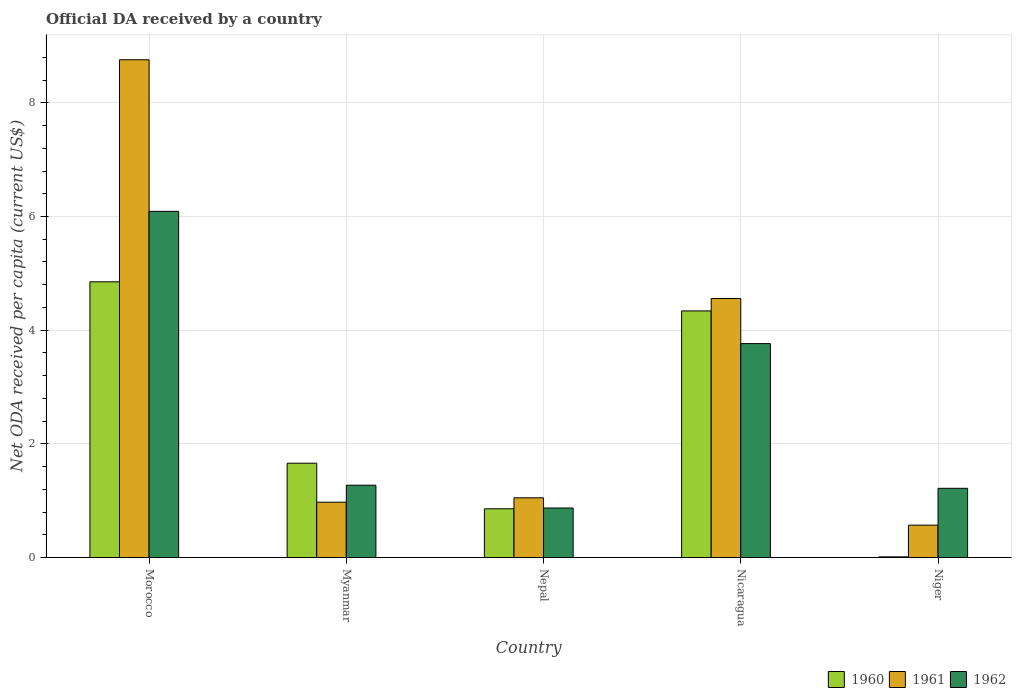How many different coloured bars are there?
Ensure brevity in your answer.  3. Are the number of bars on each tick of the X-axis equal?
Make the answer very short. Yes. How many bars are there on the 1st tick from the right?
Your answer should be very brief. 3. What is the label of the 1st group of bars from the left?
Your answer should be compact. Morocco. What is the ODA received in in 1961 in Myanmar?
Give a very brief answer. 0.97. Across all countries, what is the maximum ODA received in in 1962?
Keep it short and to the point. 6.09. Across all countries, what is the minimum ODA received in in 1961?
Keep it short and to the point. 0.57. In which country was the ODA received in in 1960 maximum?
Provide a succinct answer. Morocco. In which country was the ODA received in in 1962 minimum?
Your answer should be very brief. Nepal. What is the total ODA received in in 1962 in the graph?
Your response must be concise. 13.22. What is the difference between the ODA received in in 1962 in Morocco and that in Niger?
Offer a very short reply. 4.87. What is the difference between the ODA received in in 1962 in Myanmar and the ODA received in in 1960 in Niger?
Give a very brief answer. 1.26. What is the average ODA received in in 1961 per country?
Give a very brief answer. 3.18. What is the difference between the ODA received in of/in 1961 and ODA received in of/in 1960 in Morocco?
Provide a succinct answer. 3.91. What is the ratio of the ODA received in in 1961 in Nicaragua to that in Niger?
Your answer should be compact. 8. What is the difference between the highest and the second highest ODA received in in 1960?
Ensure brevity in your answer.  -3.19. What is the difference between the highest and the lowest ODA received in in 1960?
Make the answer very short. 4.84. Is the sum of the ODA received in in 1961 in Nepal and Niger greater than the maximum ODA received in in 1960 across all countries?
Give a very brief answer. No. What does the 1st bar from the left in Morocco represents?
Ensure brevity in your answer.  1960. Is it the case that in every country, the sum of the ODA received in in 1962 and ODA received in in 1960 is greater than the ODA received in in 1961?
Offer a terse response. Yes. How many bars are there?
Give a very brief answer. 15. How many countries are there in the graph?
Your answer should be very brief. 5. Are the values on the major ticks of Y-axis written in scientific E-notation?
Provide a succinct answer. No. Does the graph contain any zero values?
Your answer should be compact. No. Does the graph contain grids?
Make the answer very short. Yes. Where does the legend appear in the graph?
Provide a short and direct response. Bottom right. How many legend labels are there?
Offer a terse response. 3. What is the title of the graph?
Provide a succinct answer. Official DA received by a country. Does "1986" appear as one of the legend labels in the graph?
Make the answer very short. No. What is the label or title of the Y-axis?
Provide a short and direct response. Net ODA received per capita (current US$). What is the Net ODA received per capita (current US$) in 1960 in Morocco?
Your answer should be compact. 4.85. What is the Net ODA received per capita (current US$) of 1961 in Morocco?
Ensure brevity in your answer.  8.76. What is the Net ODA received per capita (current US$) in 1962 in Morocco?
Your response must be concise. 6.09. What is the Net ODA received per capita (current US$) in 1960 in Myanmar?
Your response must be concise. 1.66. What is the Net ODA received per capita (current US$) of 1961 in Myanmar?
Your answer should be compact. 0.97. What is the Net ODA received per capita (current US$) in 1962 in Myanmar?
Provide a succinct answer. 1.27. What is the Net ODA received per capita (current US$) in 1960 in Nepal?
Offer a very short reply. 0.86. What is the Net ODA received per capita (current US$) in 1961 in Nepal?
Offer a very short reply. 1.05. What is the Net ODA received per capita (current US$) in 1962 in Nepal?
Ensure brevity in your answer.  0.87. What is the Net ODA received per capita (current US$) in 1960 in Nicaragua?
Keep it short and to the point. 4.34. What is the Net ODA received per capita (current US$) in 1961 in Nicaragua?
Keep it short and to the point. 4.56. What is the Net ODA received per capita (current US$) in 1962 in Nicaragua?
Offer a very short reply. 3.76. What is the Net ODA received per capita (current US$) in 1960 in Niger?
Your response must be concise. 0.01. What is the Net ODA received per capita (current US$) in 1961 in Niger?
Provide a short and direct response. 0.57. What is the Net ODA received per capita (current US$) of 1962 in Niger?
Your response must be concise. 1.22. Across all countries, what is the maximum Net ODA received per capita (current US$) of 1960?
Provide a succinct answer. 4.85. Across all countries, what is the maximum Net ODA received per capita (current US$) in 1961?
Offer a terse response. 8.76. Across all countries, what is the maximum Net ODA received per capita (current US$) in 1962?
Your response must be concise. 6.09. Across all countries, what is the minimum Net ODA received per capita (current US$) of 1960?
Ensure brevity in your answer.  0.01. Across all countries, what is the minimum Net ODA received per capita (current US$) of 1961?
Provide a succinct answer. 0.57. Across all countries, what is the minimum Net ODA received per capita (current US$) of 1962?
Offer a terse response. 0.87. What is the total Net ODA received per capita (current US$) in 1960 in the graph?
Provide a succinct answer. 11.72. What is the total Net ODA received per capita (current US$) of 1961 in the graph?
Provide a succinct answer. 15.91. What is the total Net ODA received per capita (current US$) of 1962 in the graph?
Ensure brevity in your answer.  13.22. What is the difference between the Net ODA received per capita (current US$) in 1960 in Morocco and that in Myanmar?
Give a very brief answer. 3.19. What is the difference between the Net ODA received per capita (current US$) in 1961 in Morocco and that in Myanmar?
Your answer should be very brief. 7.78. What is the difference between the Net ODA received per capita (current US$) in 1962 in Morocco and that in Myanmar?
Your response must be concise. 4.82. What is the difference between the Net ODA received per capita (current US$) of 1960 in Morocco and that in Nepal?
Make the answer very short. 3.99. What is the difference between the Net ODA received per capita (current US$) in 1961 in Morocco and that in Nepal?
Your response must be concise. 7.71. What is the difference between the Net ODA received per capita (current US$) of 1962 in Morocco and that in Nepal?
Your answer should be very brief. 5.22. What is the difference between the Net ODA received per capita (current US$) of 1960 in Morocco and that in Nicaragua?
Ensure brevity in your answer.  0.51. What is the difference between the Net ODA received per capita (current US$) of 1961 in Morocco and that in Nicaragua?
Your answer should be compact. 4.2. What is the difference between the Net ODA received per capita (current US$) of 1962 in Morocco and that in Nicaragua?
Your answer should be very brief. 2.33. What is the difference between the Net ODA received per capita (current US$) in 1960 in Morocco and that in Niger?
Your answer should be very brief. 4.84. What is the difference between the Net ODA received per capita (current US$) of 1961 in Morocco and that in Niger?
Provide a short and direct response. 8.19. What is the difference between the Net ODA received per capita (current US$) in 1962 in Morocco and that in Niger?
Provide a short and direct response. 4.87. What is the difference between the Net ODA received per capita (current US$) in 1960 in Myanmar and that in Nepal?
Offer a very short reply. 0.8. What is the difference between the Net ODA received per capita (current US$) of 1961 in Myanmar and that in Nepal?
Provide a succinct answer. -0.08. What is the difference between the Net ODA received per capita (current US$) in 1962 in Myanmar and that in Nepal?
Provide a short and direct response. 0.4. What is the difference between the Net ODA received per capita (current US$) of 1960 in Myanmar and that in Nicaragua?
Your answer should be very brief. -2.68. What is the difference between the Net ODA received per capita (current US$) of 1961 in Myanmar and that in Nicaragua?
Keep it short and to the point. -3.58. What is the difference between the Net ODA received per capita (current US$) of 1962 in Myanmar and that in Nicaragua?
Offer a terse response. -2.49. What is the difference between the Net ODA received per capita (current US$) in 1960 in Myanmar and that in Niger?
Keep it short and to the point. 1.65. What is the difference between the Net ODA received per capita (current US$) of 1961 in Myanmar and that in Niger?
Keep it short and to the point. 0.4. What is the difference between the Net ODA received per capita (current US$) in 1962 in Myanmar and that in Niger?
Give a very brief answer. 0.05. What is the difference between the Net ODA received per capita (current US$) of 1960 in Nepal and that in Nicaragua?
Your answer should be compact. -3.48. What is the difference between the Net ODA received per capita (current US$) in 1961 in Nepal and that in Nicaragua?
Your answer should be very brief. -3.51. What is the difference between the Net ODA received per capita (current US$) of 1962 in Nepal and that in Nicaragua?
Offer a very short reply. -2.89. What is the difference between the Net ODA received per capita (current US$) in 1960 in Nepal and that in Niger?
Your answer should be compact. 0.85. What is the difference between the Net ODA received per capita (current US$) in 1961 in Nepal and that in Niger?
Your answer should be very brief. 0.48. What is the difference between the Net ODA received per capita (current US$) of 1962 in Nepal and that in Niger?
Your response must be concise. -0.35. What is the difference between the Net ODA received per capita (current US$) of 1960 in Nicaragua and that in Niger?
Keep it short and to the point. 4.33. What is the difference between the Net ODA received per capita (current US$) of 1961 in Nicaragua and that in Niger?
Make the answer very short. 3.99. What is the difference between the Net ODA received per capita (current US$) of 1962 in Nicaragua and that in Niger?
Your answer should be compact. 2.55. What is the difference between the Net ODA received per capita (current US$) in 1960 in Morocco and the Net ODA received per capita (current US$) in 1961 in Myanmar?
Your response must be concise. 3.88. What is the difference between the Net ODA received per capita (current US$) of 1960 in Morocco and the Net ODA received per capita (current US$) of 1962 in Myanmar?
Your answer should be very brief. 3.58. What is the difference between the Net ODA received per capita (current US$) of 1961 in Morocco and the Net ODA received per capita (current US$) of 1962 in Myanmar?
Provide a succinct answer. 7.48. What is the difference between the Net ODA received per capita (current US$) of 1960 in Morocco and the Net ODA received per capita (current US$) of 1961 in Nepal?
Offer a terse response. 3.8. What is the difference between the Net ODA received per capita (current US$) of 1960 in Morocco and the Net ODA received per capita (current US$) of 1962 in Nepal?
Provide a short and direct response. 3.98. What is the difference between the Net ODA received per capita (current US$) of 1961 in Morocco and the Net ODA received per capita (current US$) of 1962 in Nepal?
Offer a very short reply. 7.89. What is the difference between the Net ODA received per capita (current US$) of 1960 in Morocco and the Net ODA received per capita (current US$) of 1961 in Nicaragua?
Your answer should be very brief. 0.29. What is the difference between the Net ODA received per capita (current US$) of 1960 in Morocco and the Net ODA received per capita (current US$) of 1962 in Nicaragua?
Your answer should be compact. 1.09. What is the difference between the Net ODA received per capita (current US$) of 1961 in Morocco and the Net ODA received per capita (current US$) of 1962 in Nicaragua?
Keep it short and to the point. 4.99. What is the difference between the Net ODA received per capita (current US$) in 1960 in Morocco and the Net ODA received per capita (current US$) in 1961 in Niger?
Provide a short and direct response. 4.28. What is the difference between the Net ODA received per capita (current US$) in 1960 in Morocco and the Net ODA received per capita (current US$) in 1962 in Niger?
Give a very brief answer. 3.63. What is the difference between the Net ODA received per capita (current US$) in 1961 in Morocco and the Net ODA received per capita (current US$) in 1962 in Niger?
Offer a terse response. 7.54. What is the difference between the Net ODA received per capita (current US$) of 1960 in Myanmar and the Net ODA received per capita (current US$) of 1961 in Nepal?
Make the answer very short. 0.61. What is the difference between the Net ODA received per capita (current US$) in 1960 in Myanmar and the Net ODA received per capita (current US$) in 1962 in Nepal?
Your answer should be compact. 0.79. What is the difference between the Net ODA received per capita (current US$) in 1961 in Myanmar and the Net ODA received per capita (current US$) in 1962 in Nepal?
Your answer should be compact. 0.1. What is the difference between the Net ODA received per capita (current US$) of 1960 in Myanmar and the Net ODA received per capita (current US$) of 1961 in Nicaragua?
Offer a very short reply. -2.9. What is the difference between the Net ODA received per capita (current US$) of 1960 in Myanmar and the Net ODA received per capita (current US$) of 1962 in Nicaragua?
Offer a very short reply. -2.1. What is the difference between the Net ODA received per capita (current US$) in 1961 in Myanmar and the Net ODA received per capita (current US$) in 1962 in Nicaragua?
Your response must be concise. -2.79. What is the difference between the Net ODA received per capita (current US$) of 1960 in Myanmar and the Net ODA received per capita (current US$) of 1961 in Niger?
Your answer should be compact. 1.09. What is the difference between the Net ODA received per capita (current US$) in 1960 in Myanmar and the Net ODA received per capita (current US$) in 1962 in Niger?
Your response must be concise. 0.44. What is the difference between the Net ODA received per capita (current US$) of 1961 in Myanmar and the Net ODA received per capita (current US$) of 1962 in Niger?
Your response must be concise. -0.24. What is the difference between the Net ODA received per capita (current US$) in 1960 in Nepal and the Net ODA received per capita (current US$) in 1961 in Nicaragua?
Offer a very short reply. -3.7. What is the difference between the Net ODA received per capita (current US$) in 1960 in Nepal and the Net ODA received per capita (current US$) in 1962 in Nicaragua?
Provide a succinct answer. -2.91. What is the difference between the Net ODA received per capita (current US$) of 1961 in Nepal and the Net ODA received per capita (current US$) of 1962 in Nicaragua?
Provide a short and direct response. -2.71. What is the difference between the Net ODA received per capita (current US$) of 1960 in Nepal and the Net ODA received per capita (current US$) of 1961 in Niger?
Keep it short and to the point. 0.29. What is the difference between the Net ODA received per capita (current US$) in 1960 in Nepal and the Net ODA received per capita (current US$) in 1962 in Niger?
Provide a short and direct response. -0.36. What is the difference between the Net ODA received per capita (current US$) of 1961 in Nepal and the Net ODA received per capita (current US$) of 1962 in Niger?
Make the answer very short. -0.17. What is the difference between the Net ODA received per capita (current US$) in 1960 in Nicaragua and the Net ODA received per capita (current US$) in 1961 in Niger?
Offer a terse response. 3.77. What is the difference between the Net ODA received per capita (current US$) of 1960 in Nicaragua and the Net ODA received per capita (current US$) of 1962 in Niger?
Ensure brevity in your answer.  3.12. What is the difference between the Net ODA received per capita (current US$) in 1961 in Nicaragua and the Net ODA received per capita (current US$) in 1962 in Niger?
Give a very brief answer. 3.34. What is the average Net ODA received per capita (current US$) of 1960 per country?
Provide a succinct answer. 2.34. What is the average Net ODA received per capita (current US$) in 1961 per country?
Provide a short and direct response. 3.18. What is the average Net ODA received per capita (current US$) of 1962 per country?
Ensure brevity in your answer.  2.64. What is the difference between the Net ODA received per capita (current US$) in 1960 and Net ODA received per capita (current US$) in 1961 in Morocco?
Your answer should be compact. -3.91. What is the difference between the Net ODA received per capita (current US$) of 1960 and Net ODA received per capita (current US$) of 1962 in Morocco?
Offer a terse response. -1.24. What is the difference between the Net ODA received per capita (current US$) of 1961 and Net ODA received per capita (current US$) of 1962 in Morocco?
Your response must be concise. 2.67. What is the difference between the Net ODA received per capita (current US$) of 1960 and Net ODA received per capita (current US$) of 1961 in Myanmar?
Make the answer very short. 0.69. What is the difference between the Net ODA received per capita (current US$) in 1960 and Net ODA received per capita (current US$) in 1962 in Myanmar?
Offer a terse response. 0.39. What is the difference between the Net ODA received per capita (current US$) in 1961 and Net ODA received per capita (current US$) in 1962 in Myanmar?
Your answer should be compact. -0.3. What is the difference between the Net ODA received per capita (current US$) in 1960 and Net ODA received per capita (current US$) in 1961 in Nepal?
Offer a terse response. -0.19. What is the difference between the Net ODA received per capita (current US$) of 1960 and Net ODA received per capita (current US$) of 1962 in Nepal?
Provide a short and direct response. -0.01. What is the difference between the Net ODA received per capita (current US$) in 1961 and Net ODA received per capita (current US$) in 1962 in Nepal?
Your answer should be very brief. 0.18. What is the difference between the Net ODA received per capita (current US$) in 1960 and Net ODA received per capita (current US$) in 1961 in Nicaragua?
Your response must be concise. -0.22. What is the difference between the Net ODA received per capita (current US$) in 1960 and Net ODA received per capita (current US$) in 1962 in Nicaragua?
Make the answer very short. 0.58. What is the difference between the Net ODA received per capita (current US$) in 1961 and Net ODA received per capita (current US$) in 1962 in Nicaragua?
Provide a succinct answer. 0.79. What is the difference between the Net ODA received per capita (current US$) in 1960 and Net ODA received per capita (current US$) in 1961 in Niger?
Give a very brief answer. -0.56. What is the difference between the Net ODA received per capita (current US$) of 1960 and Net ODA received per capita (current US$) of 1962 in Niger?
Provide a short and direct response. -1.21. What is the difference between the Net ODA received per capita (current US$) in 1961 and Net ODA received per capita (current US$) in 1962 in Niger?
Make the answer very short. -0.65. What is the ratio of the Net ODA received per capita (current US$) of 1960 in Morocco to that in Myanmar?
Your answer should be very brief. 2.92. What is the ratio of the Net ODA received per capita (current US$) in 1961 in Morocco to that in Myanmar?
Offer a terse response. 9. What is the ratio of the Net ODA received per capita (current US$) in 1962 in Morocco to that in Myanmar?
Ensure brevity in your answer.  4.79. What is the ratio of the Net ODA received per capita (current US$) in 1960 in Morocco to that in Nepal?
Your answer should be very brief. 5.66. What is the ratio of the Net ODA received per capita (current US$) of 1961 in Morocco to that in Nepal?
Provide a succinct answer. 8.34. What is the ratio of the Net ODA received per capita (current US$) in 1962 in Morocco to that in Nepal?
Your response must be concise. 6.99. What is the ratio of the Net ODA received per capita (current US$) of 1960 in Morocco to that in Nicaragua?
Offer a very short reply. 1.12. What is the ratio of the Net ODA received per capita (current US$) in 1961 in Morocco to that in Nicaragua?
Your answer should be compact. 1.92. What is the ratio of the Net ODA received per capita (current US$) of 1962 in Morocco to that in Nicaragua?
Provide a short and direct response. 1.62. What is the ratio of the Net ODA received per capita (current US$) of 1960 in Morocco to that in Niger?
Provide a succinct answer. 411.71. What is the ratio of the Net ODA received per capita (current US$) in 1961 in Morocco to that in Niger?
Provide a short and direct response. 15.37. What is the ratio of the Net ODA received per capita (current US$) of 1962 in Morocco to that in Niger?
Provide a succinct answer. 5. What is the ratio of the Net ODA received per capita (current US$) in 1960 in Myanmar to that in Nepal?
Provide a short and direct response. 1.94. What is the ratio of the Net ODA received per capita (current US$) of 1961 in Myanmar to that in Nepal?
Make the answer very short. 0.93. What is the ratio of the Net ODA received per capita (current US$) in 1962 in Myanmar to that in Nepal?
Make the answer very short. 1.46. What is the ratio of the Net ODA received per capita (current US$) of 1960 in Myanmar to that in Nicaragua?
Your response must be concise. 0.38. What is the ratio of the Net ODA received per capita (current US$) of 1961 in Myanmar to that in Nicaragua?
Your answer should be compact. 0.21. What is the ratio of the Net ODA received per capita (current US$) of 1962 in Myanmar to that in Nicaragua?
Keep it short and to the point. 0.34. What is the ratio of the Net ODA received per capita (current US$) in 1960 in Myanmar to that in Niger?
Your response must be concise. 140.87. What is the ratio of the Net ODA received per capita (current US$) in 1961 in Myanmar to that in Niger?
Your response must be concise. 1.71. What is the ratio of the Net ODA received per capita (current US$) of 1962 in Myanmar to that in Niger?
Your answer should be compact. 1.04. What is the ratio of the Net ODA received per capita (current US$) in 1960 in Nepal to that in Nicaragua?
Your answer should be compact. 0.2. What is the ratio of the Net ODA received per capita (current US$) of 1961 in Nepal to that in Nicaragua?
Offer a terse response. 0.23. What is the ratio of the Net ODA received per capita (current US$) in 1962 in Nepal to that in Nicaragua?
Your answer should be compact. 0.23. What is the ratio of the Net ODA received per capita (current US$) in 1960 in Nepal to that in Niger?
Provide a short and direct response. 72.75. What is the ratio of the Net ODA received per capita (current US$) in 1961 in Nepal to that in Niger?
Your answer should be compact. 1.84. What is the ratio of the Net ODA received per capita (current US$) in 1962 in Nepal to that in Niger?
Your answer should be very brief. 0.72. What is the ratio of the Net ODA received per capita (current US$) of 1960 in Nicaragua to that in Niger?
Offer a very short reply. 368.28. What is the ratio of the Net ODA received per capita (current US$) of 1961 in Nicaragua to that in Niger?
Keep it short and to the point. 8. What is the ratio of the Net ODA received per capita (current US$) of 1962 in Nicaragua to that in Niger?
Provide a succinct answer. 3.09. What is the difference between the highest and the second highest Net ODA received per capita (current US$) in 1960?
Keep it short and to the point. 0.51. What is the difference between the highest and the second highest Net ODA received per capita (current US$) of 1961?
Your response must be concise. 4.2. What is the difference between the highest and the second highest Net ODA received per capita (current US$) in 1962?
Ensure brevity in your answer.  2.33. What is the difference between the highest and the lowest Net ODA received per capita (current US$) in 1960?
Your answer should be very brief. 4.84. What is the difference between the highest and the lowest Net ODA received per capita (current US$) of 1961?
Your response must be concise. 8.19. What is the difference between the highest and the lowest Net ODA received per capita (current US$) of 1962?
Provide a short and direct response. 5.22. 